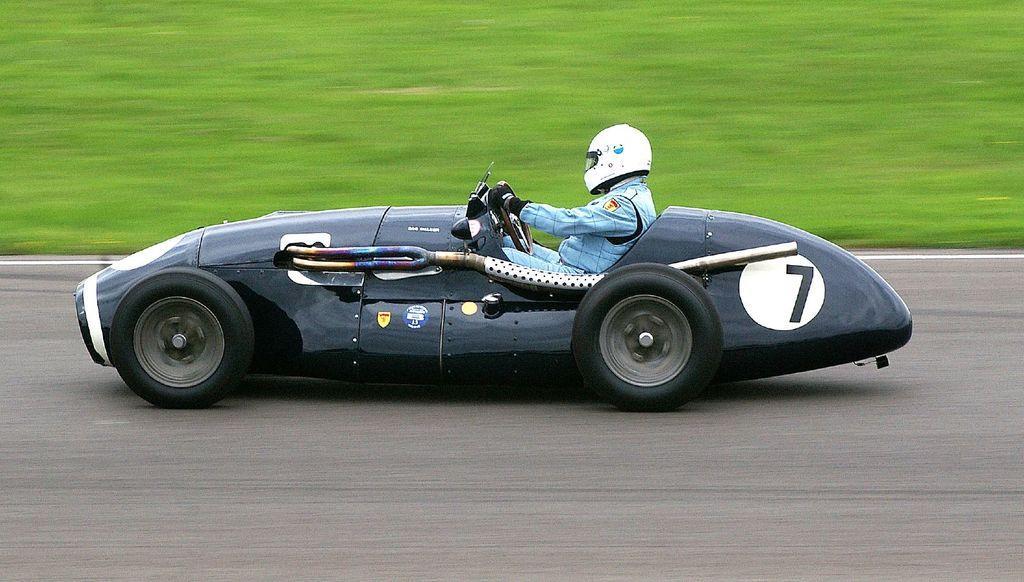Describe this image in one or two sentences. In this picture there is a person sitting and riding a vehicle and wore a helmet and gloves. In the background of the image we can see grass in green color. 